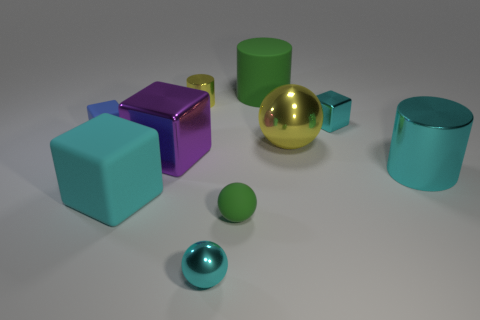Subtract all blue blocks. How many blocks are left? 3 Subtract all gray cubes. Subtract all yellow balls. How many cubes are left? 4 Subtract all cylinders. How many objects are left? 7 Subtract 1 green cylinders. How many objects are left? 9 Subtract all small shiny balls. Subtract all large green rubber objects. How many objects are left? 8 Add 8 purple metal objects. How many purple metal objects are left? 9 Add 2 green matte cubes. How many green matte cubes exist? 2 